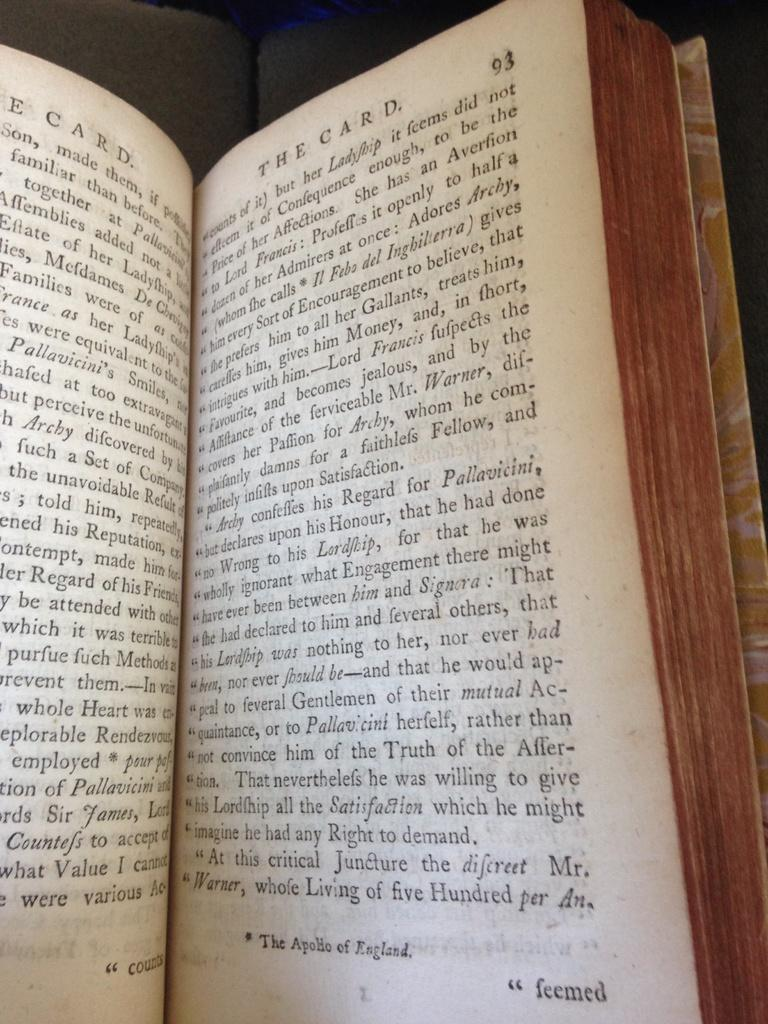<image>
Provide a brief description of the given image. Book that is saying The card from page 93. 